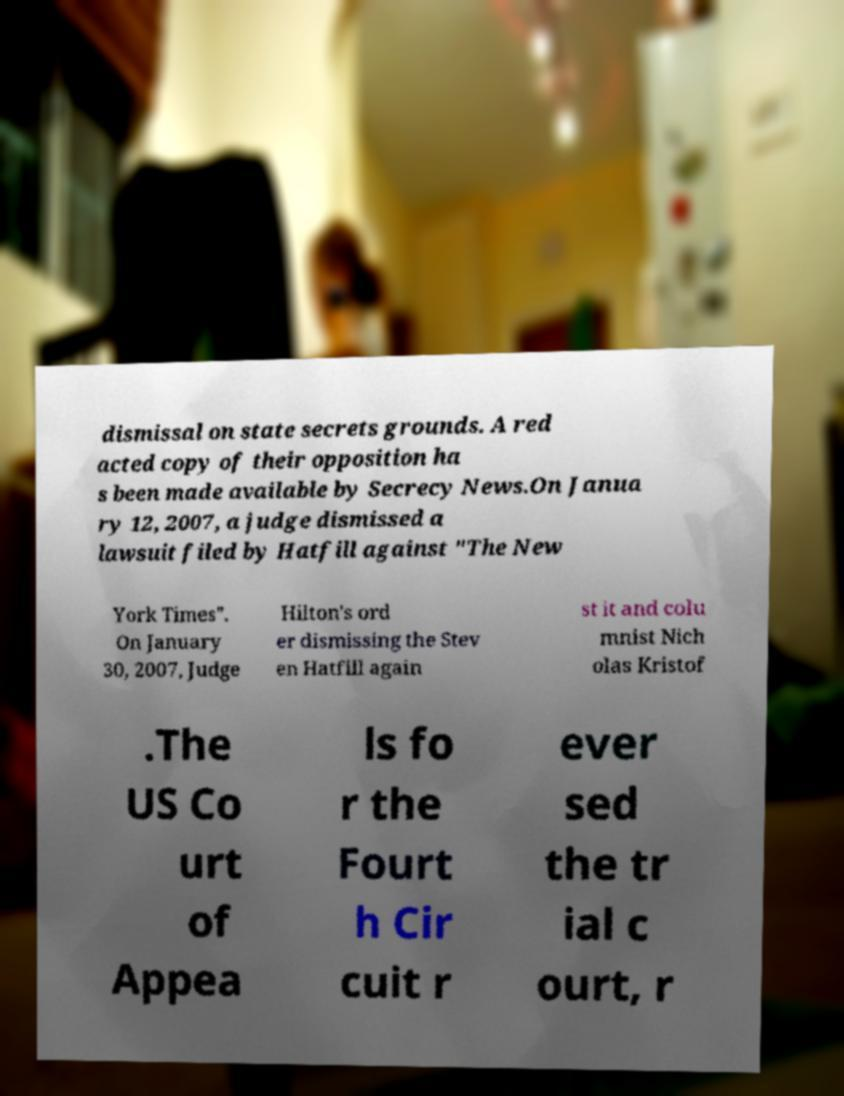Can you read and provide the text displayed in the image?This photo seems to have some interesting text. Can you extract and type it out for me? dismissal on state secrets grounds. A red acted copy of their opposition ha s been made available by Secrecy News.On Janua ry 12, 2007, a judge dismissed a lawsuit filed by Hatfill against "The New York Times". On January 30, 2007, Judge Hilton's ord er dismissing the Stev en Hatfill again st it and colu mnist Nich olas Kristof .The US Co urt of Appea ls fo r the Fourt h Cir cuit r ever sed the tr ial c ourt, r 